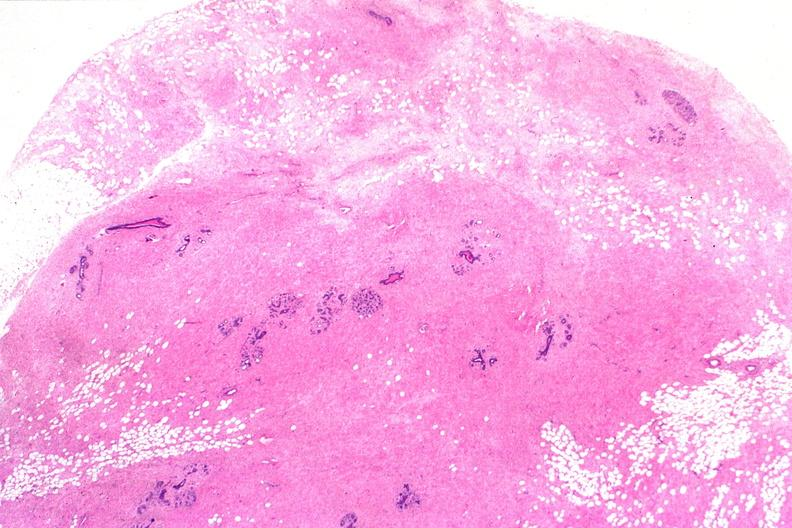where is this from?
Answer the question using a single word or phrase. Female reproductive system 